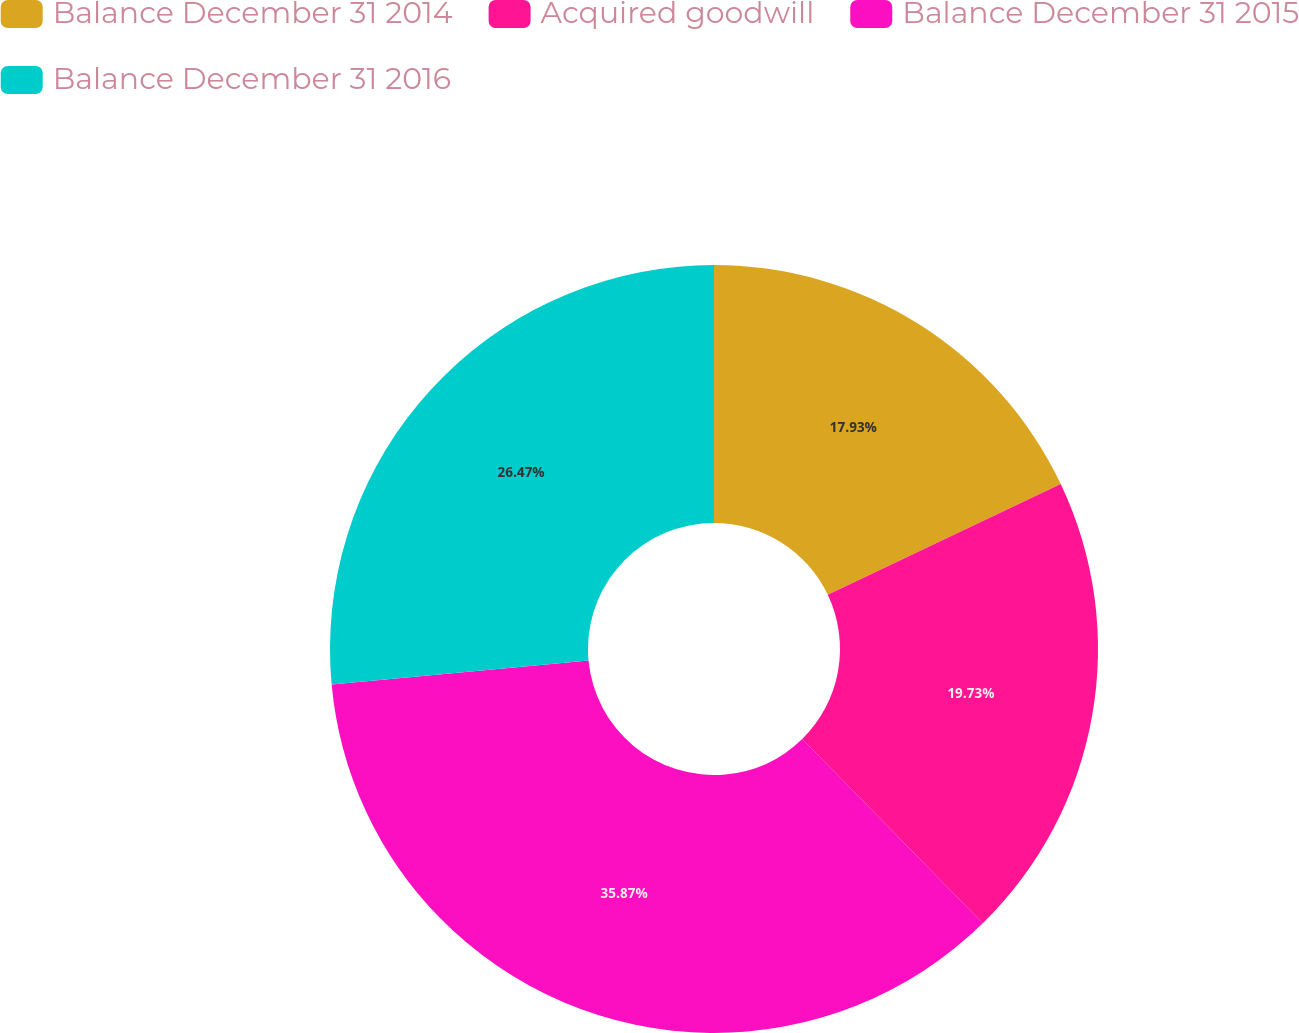<chart> <loc_0><loc_0><loc_500><loc_500><pie_chart><fcel>Balance December 31 2014<fcel>Acquired goodwill<fcel>Balance December 31 2015<fcel>Balance December 31 2016<nl><fcel>17.93%<fcel>19.73%<fcel>35.87%<fcel>26.47%<nl></chart> 